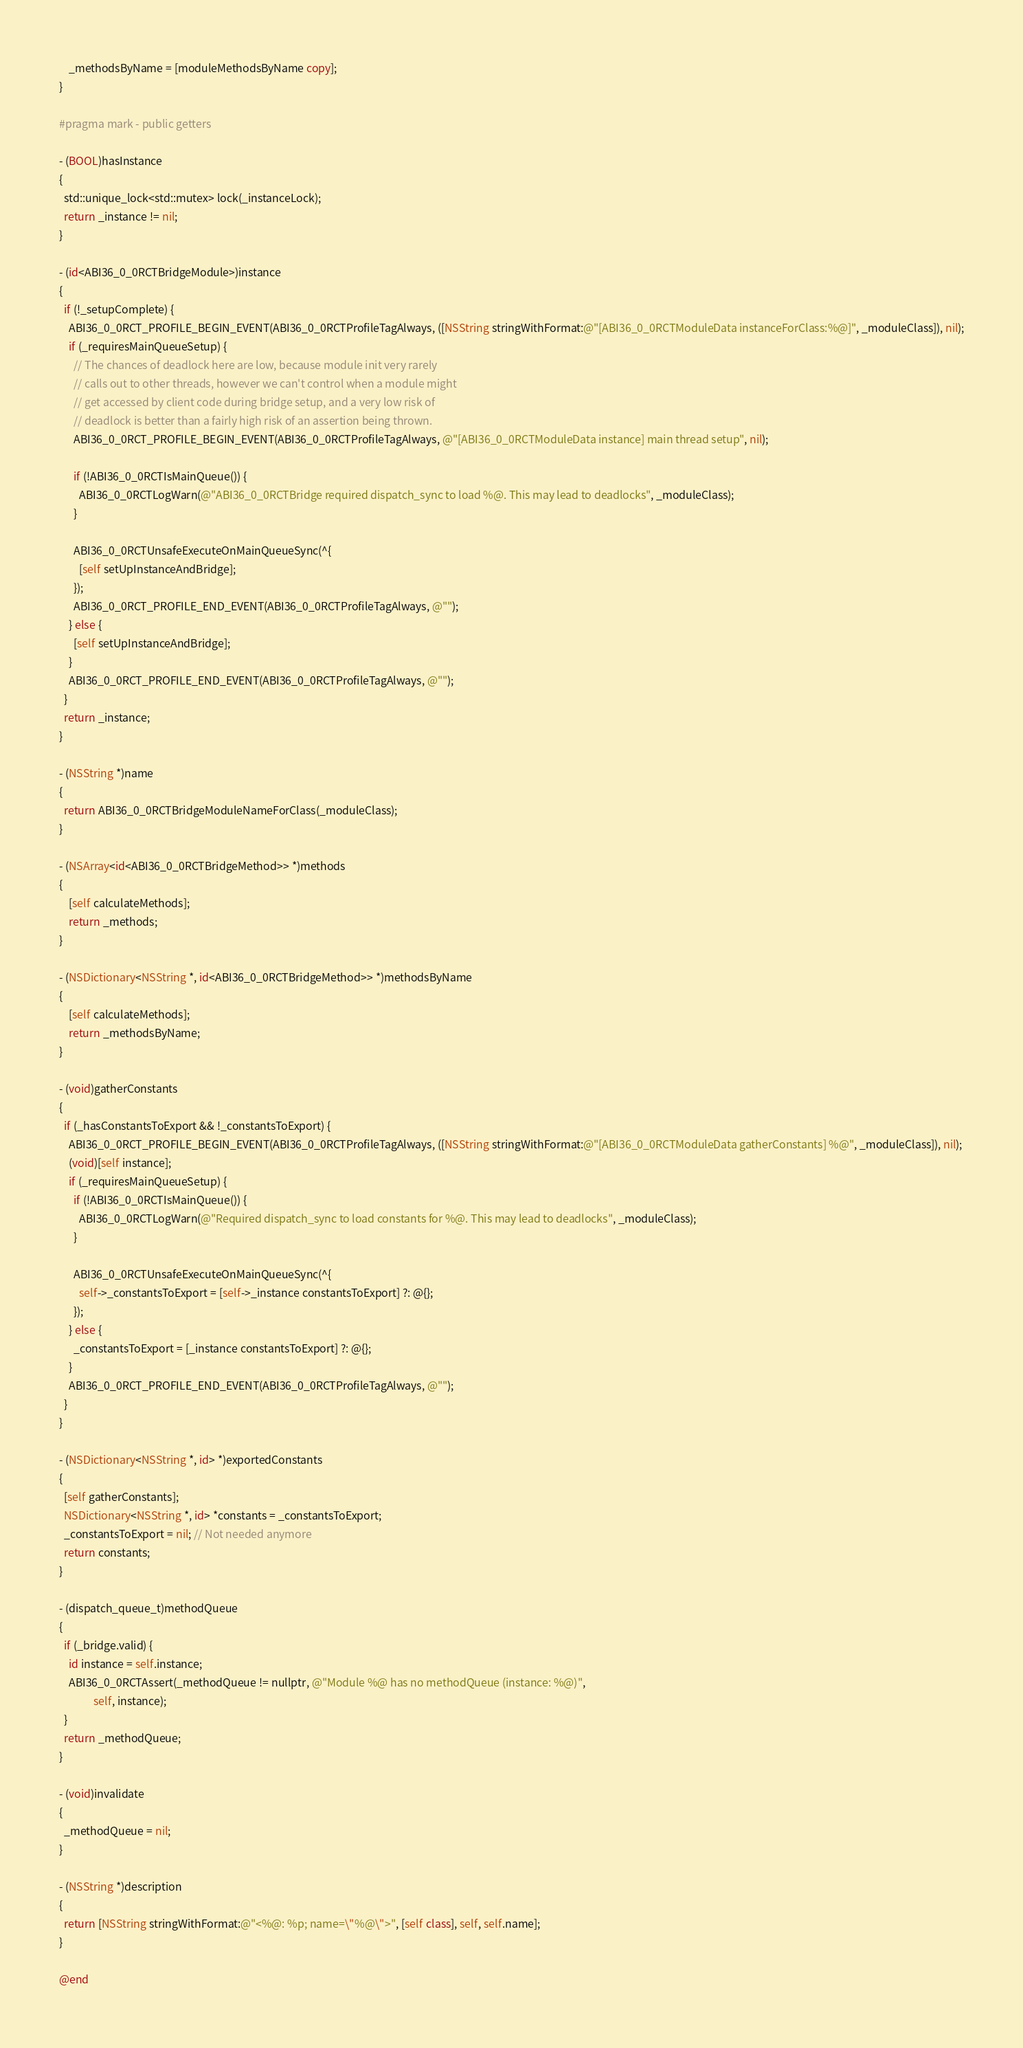<code> <loc_0><loc_0><loc_500><loc_500><_ObjectiveC_>    _methodsByName = [moduleMethodsByName copy];
}

#pragma mark - public getters

- (BOOL)hasInstance
{
  std::unique_lock<std::mutex> lock(_instanceLock);
  return _instance != nil;
}

- (id<ABI36_0_0RCTBridgeModule>)instance
{
  if (!_setupComplete) {
    ABI36_0_0RCT_PROFILE_BEGIN_EVENT(ABI36_0_0RCTProfileTagAlways, ([NSString stringWithFormat:@"[ABI36_0_0RCTModuleData instanceForClass:%@]", _moduleClass]), nil);
    if (_requiresMainQueueSetup) {
      // The chances of deadlock here are low, because module init very rarely
      // calls out to other threads, however we can't control when a module might
      // get accessed by client code during bridge setup, and a very low risk of
      // deadlock is better than a fairly high risk of an assertion being thrown.
      ABI36_0_0RCT_PROFILE_BEGIN_EVENT(ABI36_0_0RCTProfileTagAlways, @"[ABI36_0_0RCTModuleData instance] main thread setup", nil);

      if (!ABI36_0_0RCTIsMainQueue()) {
        ABI36_0_0RCTLogWarn(@"ABI36_0_0RCTBridge required dispatch_sync to load %@. This may lead to deadlocks", _moduleClass);
      }

      ABI36_0_0RCTUnsafeExecuteOnMainQueueSync(^{
        [self setUpInstanceAndBridge];
      });
      ABI36_0_0RCT_PROFILE_END_EVENT(ABI36_0_0RCTProfileTagAlways, @"");
    } else {
      [self setUpInstanceAndBridge];
    }
    ABI36_0_0RCT_PROFILE_END_EVENT(ABI36_0_0RCTProfileTagAlways, @"");
  }
  return _instance;
}

- (NSString *)name
{
  return ABI36_0_0RCTBridgeModuleNameForClass(_moduleClass);
}

- (NSArray<id<ABI36_0_0RCTBridgeMethod>> *)methods
{
    [self calculateMethods];
    return _methods;
}

- (NSDictionary<NSString *, id<ABI36_0_0RCTBridgeMethod>> *)methodsByName
{
    [self calculateMethods];
    return _methodsByName;
}

- (void)gatherConstants
{
  if (_hasConstantsToExport && !_constantsToExport) {
    ABI36_0_0RCT_PROFILE_BEGIN_EVENT(ABI36_0_0RCTProfileTagAlways, ([NSString stringWithFormat:@"[ABI36_0_0RCTModuleData gatherConstants] %@", _moduleClass]), nil);
    (void)[self instance];
    if (_requiresMainQueueSetup) {
      if (!ABI36_0_0RCTIsMainQueue()) {
        ABI36_0_0RCTLogWarn(@"Required dispatch_sync to load constants for %@. This may lead to deadlocks", _moduleClass);
      }

      ABI36_0_0RCTUnsafeExecuteOnMainQueueSync(^{
        self->_constantsToExport = [self->_instance constantsToExport] ?: @{};
      });
    } else {
      _constantsToExport = [_instance constantsToExport] ?: @{};
    }
    ABI36_0_0RCT_PROFILE_END_EVENT(ABI36_0_0RCTProfileTagAlways, @"");
  }
}

- (NSDictionary<NSString *, id> *)exportedConstants
{
  [self gatherConstants];
  NSDictionary<NSString *, id> *constants = _constantsToExport;
  _constantsToExport = nil; // Not needed anymore
  return constants;
}

- (dispatch_queue_t)methodQueue
{
  if (_bridge.valid) {
    id instance = self.instance;
    ABI36_0_0RCTAssert(_methodQueue != nullptr, @"Module %@ has no methodQueue (instance: %@)",
              self, instance);
  }
  return _methodQueue;
}

- (void)invalidate
{
  _methodQueue = nil;
}

- (NSString *)description
{
  return [NSString stringWithFormat:@"<%@: %p; name=\"%@\">", [self class], self, self.name];
}

@end
</code> 